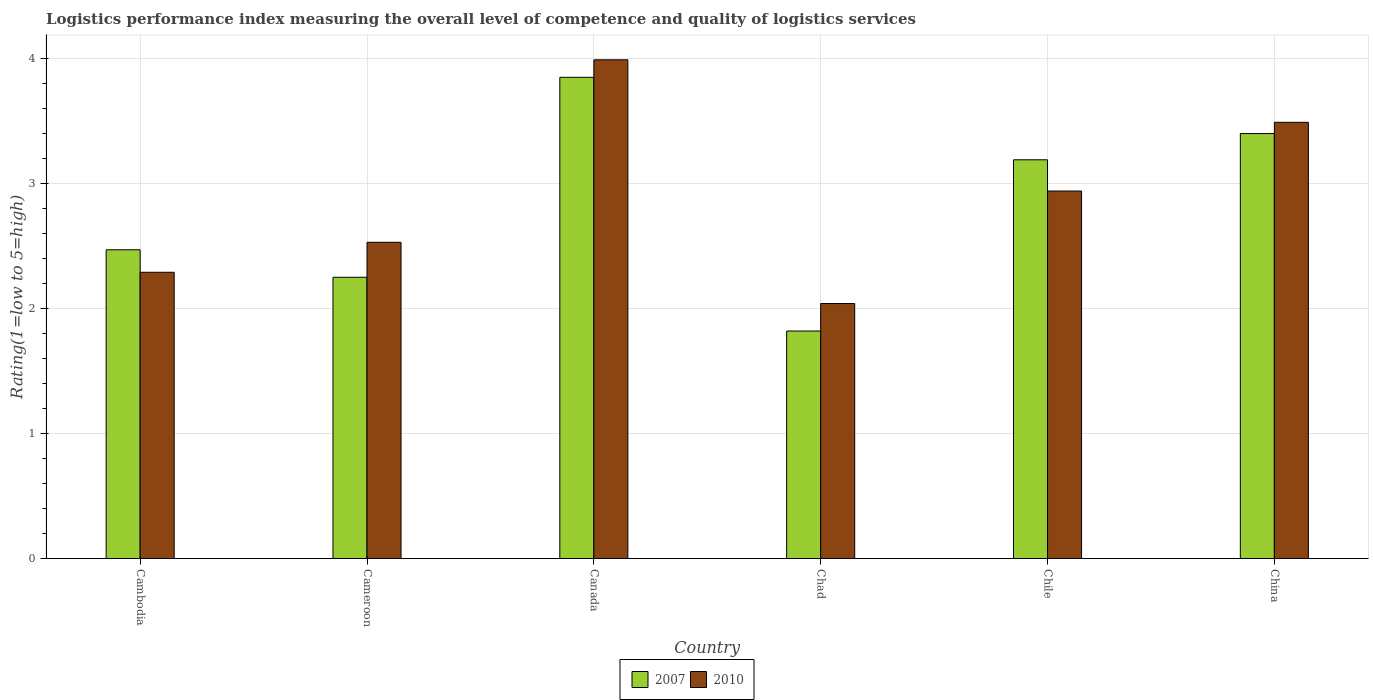How many different coloured bars are there?
Give a very brief answer. 2. Are the number of bars on each tick of the X-axis equal?
Your response must be concise. Yes. How many bars are there on the 2nd tick from the left?
Your answer should be very brief. 2. How many bars are there on the 4th tick from the right?
Make the answer very short. 2. What is the label of the 2nd group of bars from the left?
Keep it short and to the point. Cameroon. What is the Logistic performance index in 2010 in China?
Your answer should be very brief. 3.49. Across all countries, what is the maximum Logistic performance index in 2007?
Offer a very short reply. 3.85. Across all countries, what is the minimum Logistic performance index in 2010?
Your answer should be very brief. 2.04. In which country was the Logistic performance index in 2007 maximum?
Provide a succinct answer. Canada. In which country was the Logistic performance index in 2010 minimum?
Offer a very short reply. Chad. What is the total Logistic performance index in 2010 in the graph?
Your answer should be compact. 17.28. What is the difference between the Logistic performance index in 2010 in Cambodia and that in Chile?
Ensure brevity in your answer.  -0.65. What is the difference between the Logistic performance index in 2007 in Cameroon and the Logistic performance index in 2010 in Chile?
Make the answer very short. -0.69. What is the average Logistic performance index in 2010 per country?
Provide a short and direct response. 2.88. What is the difference between the Logistic performance index of/in 2007 and Logistic performance index of/in 2010 in Chad?
Ensure brevity in your answer.  -0.22. In how many countries, is the Logistic performance index in 2010 greater than 2?
Keep it short and to the point. 6. What is the ratio of the Logistic performance index in 2007 in Canada to that in Chad?
Give a very brief answer. 2.12. Is the Logistic performance index in 2007 in Cambodia less than that in China?
Keep it short and to the point. Yes. Is the difference between the Logistic performance index in 2007 in Cambodia and China greater than the difference between the Logistic performance index in 2010 in Cambodia and China?
Offer a very short reply. Yes. What is the difference between the highest and the second highest Logistic performance index in 2007?
Provide a succinct answer. -0.45. What is the difference between the highest and the lowest Logistic performance index in 2010?
Your answer should be very brief. 1.95. In how many countries, is the Logistic performance index in 2007 greater than the average Logistic performance index in 2007 taken over all countries?
Give a very brief answer. 3. Is the sum of the Logistic performance index in 2010 in Chile and China greater than the maximum Logistic performance index in 2007 across all countries?
Offer a very short reply. Yes. Are the values on the major ticks of Y-axis written in scientific E-notation?
Your answer should be very brief. No. Does the graph contain any zero values?
Make the answer very short. No. Where does the legend appear in the graph?
Offer a very short reply. Bottom center. How many legend labels are there?
Your answer should be very brief. 2. What is the title of the graph?
Your response must be concise. Logistics performance index measuring the overall level of competence and quality of logistics services. What is the label or title of the Y-axis?
Make the answer very short. Rating(1=low to 5=high). What is the Rating(1=low to 5=high) in 2007 in Cambodia?
Your answer should be very brief. 2.47. What is the Rating(1=low to 5=high) of 2010 in Cambodia?
Your answer should be very brief. 2.29. What is the Rating(1=low to 5=high) of 2007 in Cameroon?
Make the answer very short. 2.25. What is the Rating(1=low to 5=high) in 2010 in Cameroon?
Ensure brevity in your answer.  2.53. What is the Rating(1=low to 5=high) in 2007 in Canada?
Your answer should be compact. 3.85. What is the Rating(1=low to 5=high) in 2010 in Canada?
Offer a very short reply. 3.99. What is the Rating(1=low to 5=high) in 2007 in Chad?
Your response must be concise. 1.82. What is the Rating(1=low to 5=high) in 2010 in Chad?
Provide a short and direct response. 2.04. What is the Rating(1=low to 5=high) in 2007 in Chile?
Provide a succinct answer. 3.19. What is the Rating(1=low to 5=high) in 2010 in Chile?
Keep it short and to the point. 2.94. What is the Rating(1=low to 5=high) in 2007 in China?
Keep it short and to the point. 3.4. What is the Rating(1=low to 5=high) in 2010 in China?
Your answer should be very brief. 3.49. Across all countries, what is the maximum Rating(1=low to 5=high) of 2007?
Keep it short and to the point. 3.85. Across all countries, what is the maximum Rating(1=low to 5=high) of 2010?
Keep it short and to the point. 3.99. Across all countries, what is the minimum Rating(1=low to 5=high) in 2007?
Keep it short and to the point. 1.82. Across all countries, what is the minimum Rating(1=low to 5=high) in 2010?
Your response must be concise. 2.04. What is the total Rating(1=low to 5=high) of 2007 in the graph?
Give a very brief answer. 16.98. What is the total Rating(1=low to 5=high) of 2010 in the graph?
Offer a very short reply. 17.28. What is the difference between the Rating(1=low to 5=high) of 2007 in Cambodia and that in Cameroon?
Ensure brevity in your answer.  0.22. What is the difference between the Rating(1=low to 5=high) in 2010 in Cambodia and that in Cameroon?
Offer a terse response. -0.24. What is the difference between the Rating(1=low to 5=high) in 2007 in Cambodia and that in Canada?
Provide a succinct answer. -1.38. What is the difference between the Rating(1=low to 5=high) in 2007 in Cambodia and that in Chad?
Your answer should be very brief. 0.65. What is the difference between the Rating(1=low to 5=high) of 2007 in Cambodia and that in Chile?
Provide a short and direct response. -0.72. What is the difference between the Rating(1=low to 5=high) of 2010 in Cambodia and that in Chile?
Your answer should be compact. -0.65. What is the difference between the Rating(1=low to 5=high) in 2007 in Cambodia and that in China?
Give a very brief answer. -0.93. What is the difference between the Rating(1=low to 5=high) in 2010 in Cambodia and that in China?
Keep it short and to the point. -1.2. What is the difference between the Rating(1=low to 5=high) of 2010 in Cameroon and that in Canada?
Your answer should be compact. -1.46. What is the difference between the Rating(1=low to 5=high) of 2007 in Cameroon and that in Chad?
Keep it short and to the point. 0.43. What is the difference between the Rating(1=low to 5=high) in 2010 in Cameroon and that in Chad?
Keep it short and to the point. 0.49. What is the difference between the Rating(1=low to 5=high) of 2007 in Cameroon and that in Chile?
Give a very brief answer. -0.94. What is the difference between the Rating(1=low to 5=high) of 2010 in Cameroon and that in Chile?
Your answer should be compact. -0.41. What is the difference between the Rating(1=low to 5=high) in 2007 in Cameroon and that in China?
Your answer should be compact. -1.15. What is the difference between the Rating(1=low to 5=high) in 2010 in Cameroon and that in China?
Offer a very short reply. -0.96. What is the difference between the Rating(1=low to 5=high) in 2007 in Canada and that in Chad?
Offer a terse response. 2.03. What is the difference between the Rating(1=low to 5=high) in 2010 in Canada and that in Chad?
Ensure brevity in your answer.  1.95. What is the difference between the Rating(1=low to 5=high) of 2007 in Canada and that in Chile?
Ensure brevity in your answer.  0.66. What is the difference between the Rating(1=low to 5=high) in 2007 in Canada and that in China?
Provide a short and direct response. 0.45. What is the difference between the Rating(1=low to 5=high) of 2010 in Canada and that in China?
Make the answer very short. 0.5. What is the difference between the Rating(1=low to 5=high) of 2007 in Chad and that in Chile?
Keep it short and to the point. -1.37. What is the difference between the Rating(1=low to 5=high) in 2007 in Chad and that in China?
Offer a very short reply. -1.58. What is the difference between the Rating(1=low to 5=high) of 2010 in Chad and that in China?
Give a very brief answer. -1.45. What is the difference between the Rating(1=low to 5=high) in 2007 in Chile and that in China?
Ensure brevity in your answer.  -0.21. What is the difference between the Rating(1=low to 5=high) of 2010 in Chile and that in China?
Offer a very short reply. -0.55. What is the difference between the Rating(1=low to 5=high) in 2007 in Cambodia and the Rating(1=low to 5=high) in 2010 in Cameroon?
Offer a very short reply. -0.06. What is the difference between the Rating(1=low to 5=high) of 2007 in Cambodia and the Rating(1=low to 5=high) of 2010 in Canada?
Provide a succinct answer. -1.52. What is the difference between the Rating(1=low to 5=high) in 2007 in Cambodia and the Rating(1=low to 5=high) in 2010 in Chad?
Offer a terse response. 0.43. What is the difference between the Rating(1=low to 5=high) in 2007 in Cambodia and the Rating(1=low to 5=high) in 2010 in Chile?
Your answer should be compact. -0.47. What is the difference between the Rating(1=low to 5=high) in 2007 in Cambodia and the Rating(1=low to 5=high) in 2010 in China?
Keep it short and to the point. -1.02. What is the difference between the Rating(1=low to 5=high) of 2007 in Cameroon and the Rating(1=low to 5=high) of 2010 in Canada?
Your answer should be very brief. -1.74. What is the difference between the Rating(1=low to 5=high) of 2007 in Cameroon and the Rating(1=low to 5=high) of 2010 in Chad?
Provide a succinct answer. 0.21. What is the difference between the Rating(1=low to 5=high) of 2007 in Cameroon and the Rating(1=low to 5=high) of 2010 in Chile?
Make the answer very short. -0.69. What is the difference between the Rating(1=low to 5=high) of 2007 in Cameroon and the Rating(1=low to 5=high) of 2010 in China?
Offer a very short reply. -1.24. What is the difference between the Rating(1=low to 5=high) in 2007 in Canada and the Rating(1=low to 5=high) in 2010 in Chad?
Your response must be concise. 1.81. What is the difference between the Rating(1=low to 5=high) of 2007 in Canada and the Rating(1=low to 5=high) of 2010 in Chile?
Your response must be concise. 0.91. What is the difference between the Rating(1=low to 5=high) of 2007 in Canada and the Rating(1=low to 5=high) of 2010 in China?
Provide a succinct answer. 0.36. What is the difference between the Rating(1=low to 5=high) of 2007 in Chad and the Rating(1=low to 5=high) of 2010 in Chile?
Provide a succinct answer. -1.12. What is the difference between the Rating(1=low to 5=high) in 2007 in Chad and the Rating(1=low to 5=high) in 2010 in China?
Your response must be concise. -1.67. What is the average Rating(1=low to 5=high) of 2007 per country?
Make the answer very short. 2.83. What is the average Rating(1=low to 5=high) of 2010 per country?
Offer a terse response. 2.88. What is the difference between the Rating(1=low to 5=high) of 2007 and Rating(1=low to 5=high) of 2010 in Cambodia?
Your answer should be very brief. 0.18. What is the difference between the Rating(1=low to 5=high) of 2007 and Rating(1=low to 5=high) of 2010 in Cameroon?
Make the answer very short. -0.28. What is the difference between the Rating(1=low to 5=high) of 2007 and Rating(1=low to 5=high) of 2010 in Canada?
Your response must be concise. -0.14. What is the difference between the Rating(1=low to 5=high) in 2007 and Rating(1=low to 5=high) in 2010 in Chad?
Give a very brief answer. -0.22. What is the difference between the Rating(1=low to 5=high) in 2007 and Rating(1=low to 5=high) in 2010 in China?
Your answer should be very brief. -0.09. What is the ratio of the Rating(1=low to 5=high) of 2007 in Cambodia to that in Cameroon?
Give a very brief answer. 1.1. What is the ratio of the Rating(1=low to 5=high) of 2010 in Cambodia to that in Cameroon?
Ensure brevity in your answer.  0.91. What is the ratio of the Rating(1=low to 5=high) of 2007 in Cambodia to that in Canada?
Provide a short and direct response. 0.64. What is the ratio of the Rating(1=low to 5=high) in 2010 in Cambodia to that in Canada?
Offer a terse response. 0.57. What is the ratio of the Rating(1=low to 5=high) of 2007 in Cambodia to that in Chad?
Make the answer very short. 1.36. What is the ratio of the Rating(1=low to 5=high) in 2010 in Cambodia to that in Chad?
Offer a very short reply. 1.12. What is the ratio of the Rating(1=low to 5=high) in 2007 in Cambodia to that in Chile?
Provide a short and direct response. 0.77. What is the ratio of the Rating(1=low to 5=high) in 2010 in Cambodia to that in Chile?
Provide a short and direct response. 0.78. What is the ratio of the Rating(1=low to 5=high) in 2007 in Cambodia to that in China?
Your answer should be very brief. 0.73. What is the ratio of the Rating(1=low to 5=high) of 2010 in Cambodia to that in China?
Make the answer very short. 0.66. What is the ratio of the Rating(1=low to 5=high) of 2007 in Cameroon to that in Canada?
Your answer should be very brief. 0.58. What is the ratio of the Rating(1=low to 5=high) of 2010 in Cameroon to that in Canada?
Give a very brief answer. 0.63. What is the ratio of the Rating(1=low to 5=high) in 2007 in Cameroon to that in Chad?
Provide a succinct answer. 1.24. What is the ratio of the Rating(1=low to 5=high) of 2010 in Cameroon to that in Chad?
Keep it short and to the point. 1.24. What is the ratio of the Rating(1=low to 5=high) of 2007 in Cameroon to that in Chile?
Offer a terse response. 0.71. What is the ratio of the Rating(1=low to 5=high) in 2010 in Cameroon to that in Chile?
Keep it short and to the point. 0.86. What is the ratio of the Rating(1=low to 5=high) in 2007 in Cameroon to that in China?
Provide a short and direct response. 0.66. What is the ratio of the Rating(1=low to 5=high) in 2010 in Cameroon to that in China?
Make the answer very short. 0.72. What is the ratio of the Rating(1=low to 5=high) in 2007 in Canada to that in Chad?
Offer a very short reply. 2.12. What is the ratio of the Rating(1=low to 5=high) of 2010 in Canada to that in Chad?
Ensure brevity in your answer.  1.96. What is the ratio of the Rating(1=low to 5=high) in 2007 in Canada to that in Chile?
Offer a very short reply. 1.21. What is the ratio of the Rating(1=low to 5=high) in 2010 in Canada to that in Chile?
Offer a very short reply. 1.36. What is the ratio of the Rating(1=low to 5=high) in 2007 in Canada to that in China?
Provide a succinct answer. 1.13. What is the ratio of the Rating(1=low to 5=high) in 2010 in Canada to that in China?
Your answer should be compact. 1.14. What is the ratio of the Rating(1=low to 5=high) in 2007 in Chad to that in Chile?
Keep it short and to the point. 0.57. What is the ratio of the Rating(1=low to 5=high) of 2010 in Chad to that in Chile?
Offer a very short reply. 0.69. What is the ratio of the Rating(1=low to 5=high) of 2007 in Chad to that in China?
Your response must be concise. 0.54. What is the ratio of the Rating(1=low to 5=high) of 2010 in Chad to that in China?
Ensure brevity in your answer.  0.58. What is the ratio of the Rating(1=low to 5=high) of 2007 in Chile to that in China?
Provide a succinct answer. 0.94. What is the ratio of the Rating(1=low to 5=high) of 2010 in Chile to that in China?
Your answer should be very brief. 0.84. What is the difference between the highest and the second highest Rating(1=low to 5=high) in 2007?
Your answer should be very brief. 0.45. What is the difference between the highest and the lowest Rating(1=low to 5=high) of 2007?
Provide a succinct answer. 2.03. What is the difference between the highest and the lowest Rating(1=low to 5=high) in 2010?
Give a very brief answer. 1.95. 